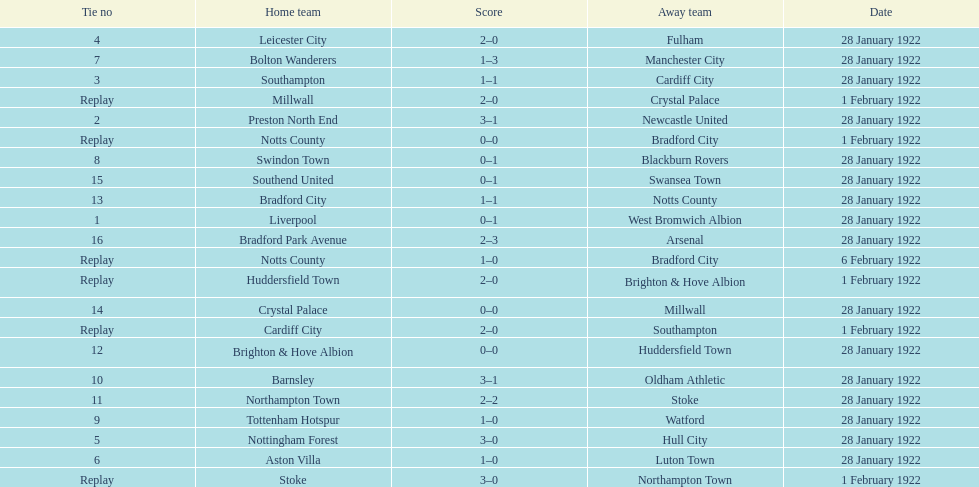What is the number of points scored on 6 february 1922? 1. 